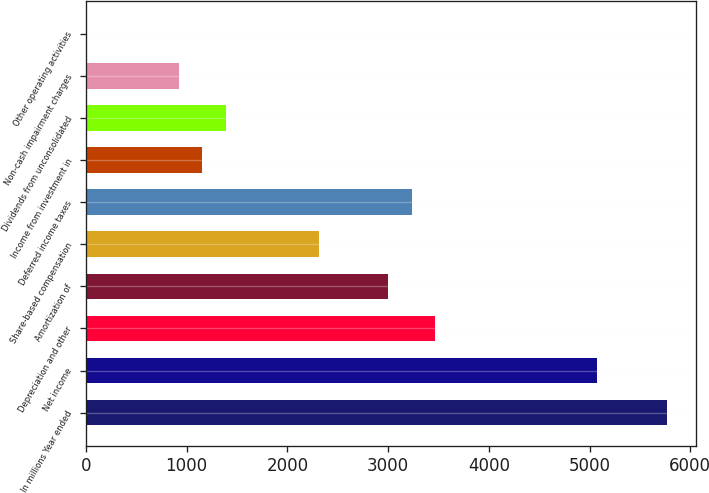Convert chart to OTSL. <chart><loc_0><loc_0><loc_500><loc_500><bar_chart><fcel>In millions Year ended<fcel>Net income<fcel>Depreciation and other<fcel>Amortization of<fcel>Share-based compensation<fcel>Deferred income taxes<fcel>Income from investment in<fcel>Dividends from unconsolidated<fcel>Non-cash impairment charges<fcel>Other operating activities<nl><fcel>5769<fcel>5077.2<fcel>3463<fcel>3001.8<fcel>2310<fcel>3232.4<fcel>1157<fcel>1387.6<fcel>926.4<fcel>4<nl></chart> 